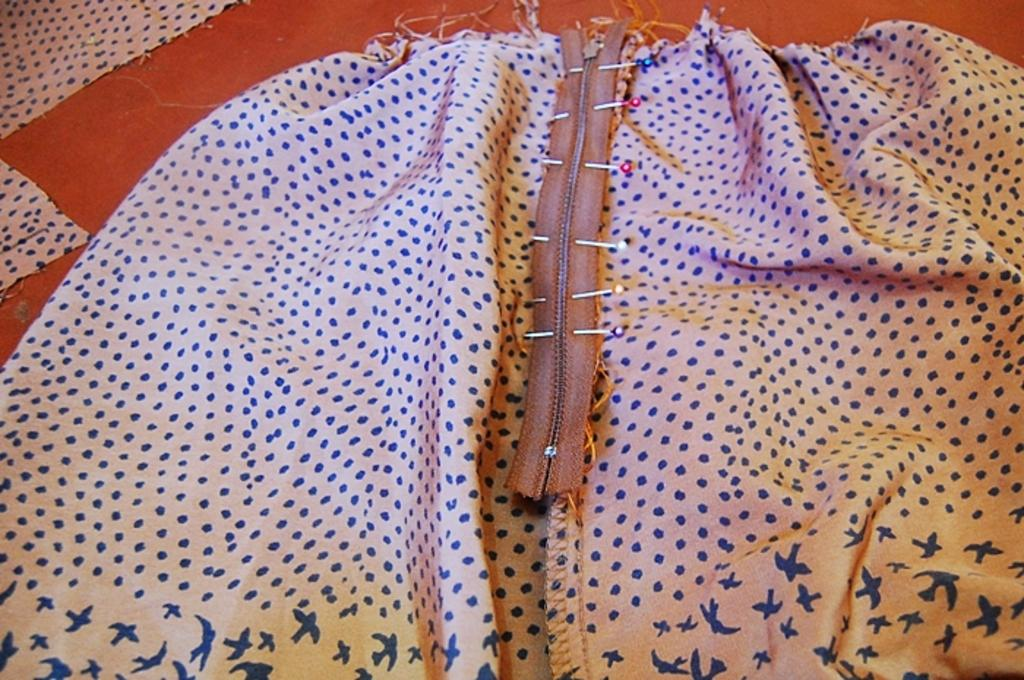What type of items can be seen in the image? There are clothes, a zip, and needles in the image. Where are these items located? These items are placed on a platform. What feature can be found on some of the clothes? There is a zip on some of the clothes. What tool is used for sewing in the image? Needles are used for sewing in the image. Can you see a tail on the tiger in the image? There is no tiger present in the image, so there is no tail to be seen. What letter is written on the clothes in the image? The provided facts do not mention any letters or words on the clothes, so we cannot determine if any letters are present. 